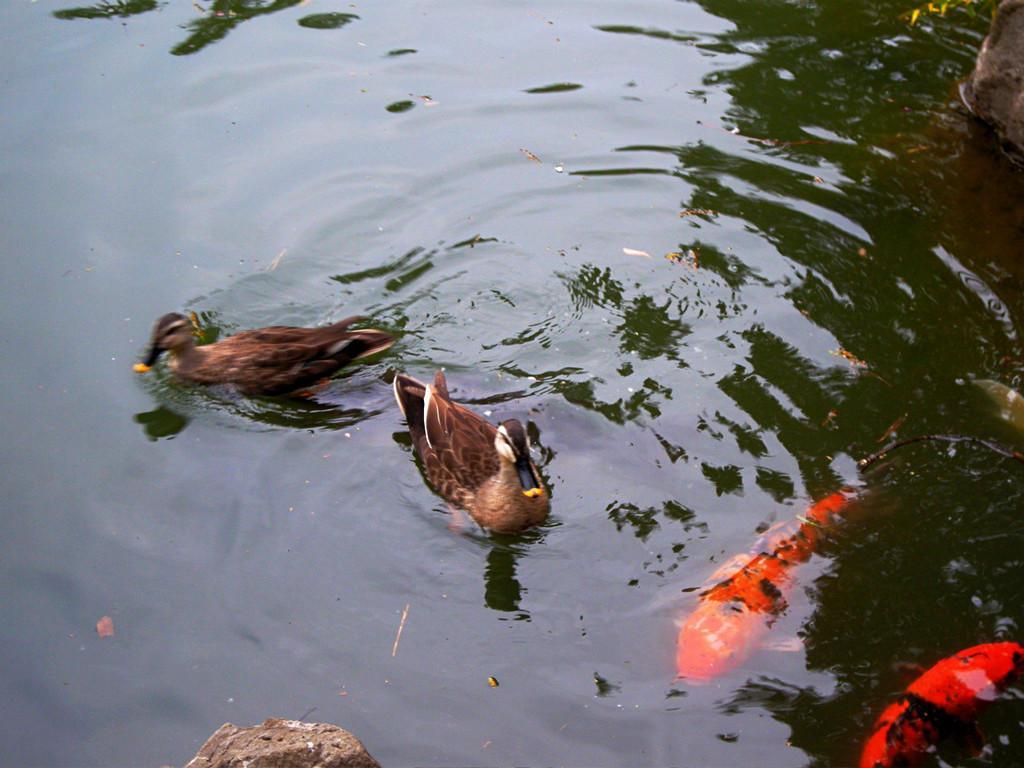How would you summarize this image in a sentence or two? In this picture we can see a water body. In the middle of the picture there are ducks. On the right we can see fishes inside the water. At the bottom there is a rock like object. 